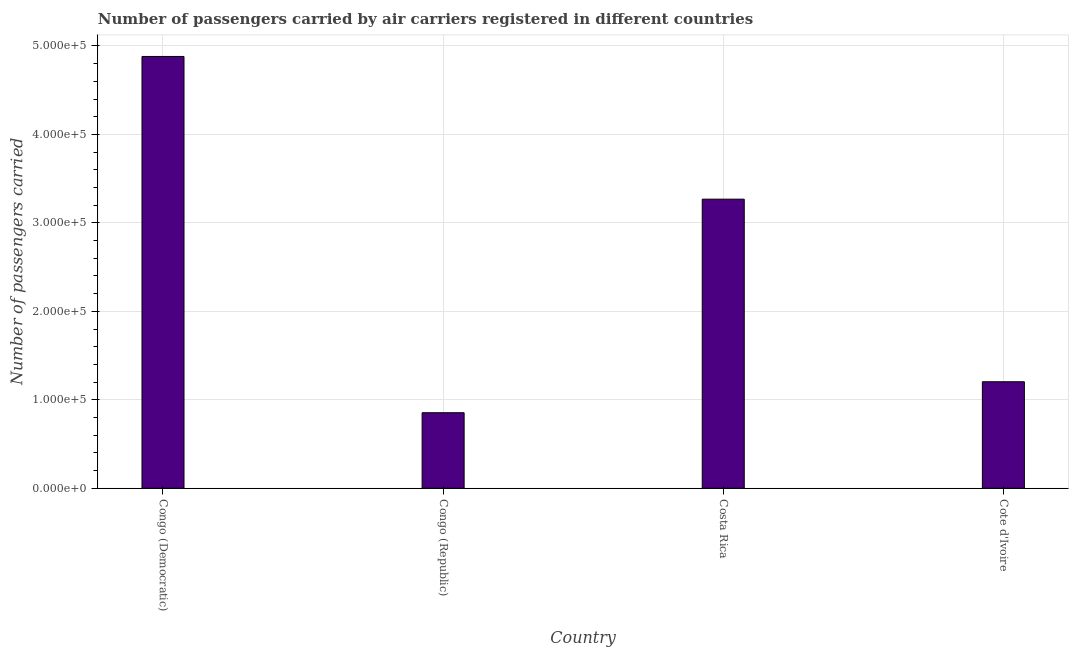Does the graph contain any zero values?
Make the answer very short. No. What is the title of the graph?
Ensure brevity in your answer.  Number of passengers carried by air carriers registered in different countries. What is the label or title of the Y-axis?
Keep it short and to the point. Number of passengers carried. What is the number of passengers carried in Costa Rica?
Offer a very short reply. 3.27e+05. Across all countries, what is the maximum number of passengers carried?
Your response must be concise. 4.88e+05. Across all countries, what is the minimum number of passengers carried?
Provide a succinct answer. 8.54e+04. In which country was the number of passengers carried maximum?
Keep it short and to the point. Congo (Democratic). In which country was the number of passengers carried minimum?
Make the answer very short. Congo (Republic). What is the sum of the number of passengers carried?
Your answer should be very brief. 1.02e+06. What is the difference between the number of passengers carried in Congo (Republic) and Cote d'Ivoire?
Make the answer very short. -3.50e+04. What is the average number of passengers carried per country?
Provide a succinct answer. 2.55e+05. What is the median number of passengers carried?
Ensure brevity in your answer.  2.24e+05. What is the ratio of the number of passengers carried in Congo (Republic) to that in Cote d'Ivoire?
Offer a very short reply. 0.71. Is the number of passengers carried in Congo (Democratic) less than that in Cote d'Ivoire?
Ensure brevity in your answer.  No. What is the difference between the highest and the second highest number of passengers carried?
Provide a succinct answer. 1.61e+05. What is the difference between the highest and the lowest number of passengers carried?
Make the answer very short. 4.03e+05. How many bars are there?
Your response must be concise. 4. What is the difference between two consecutive major ticks on the Y-axis?
Keep it short and to the point. 1.00e+05. What is the Number of passengers carried in Congo (Democratic)?
Make the answer very short. 4.88e+05. What is the Number of passengers carried in Congo (Republic)?
Ensure brevity in your answer.  8.54e+04. What is the Number of passengers carried of Costa Rica?
Keep it short and to the point. 3.27e+05. What is the Number of passengers carried in Cote d'Ivoire?
Your answer should be very brief. 1.20e+05. What is the difference between the Number of passengers carried in Congo (Democratic) and Congo (Republic)?
Keep it short and to the point. 4.03e+05. What is the difference between the Number of passengers carried in Congo (Democratic) and Costa Rica?
Ensure brevity in your answer.  1.61e+05. What is the difference between the Number of passengers carried in Congo (Democratic) and Cote d'Ivoire?
Give a very brief answer. 3.68e+05. What is the difference between the Number of passengers carried in Congo (Republic) and Costa Rica?
Your answer should be very brief. -2.41e+05. What is the difference between the Number of passengers carried in Congo (Republic) and Cote d'Ivoire?
Give a very brief answer. -3.50e+04. What is the difference between the Number of passengers carried in Costa Rica and Cote d'Ivoire?
Your answer should be very brief. 2.06e+05. What is the ratio of the Number of passengers carried in Congo (Democratic) to that in Congo (Republic)?
Provide a short and direct response. 5.71. What is the ratio of the Number of passengers carried in Congo (Democratic) to that in Costa Rica?
Your response must be concise. 1.49. What is the ratio of the Number of passengers carried in Congo (Democratic) to that in Cote d'Ivoire?
Offer a terse response. 4.05. What is the ratio of the Number of passengers carried in Congo (Republic) to that in Costa Rica?
Give a very brief answer. 0.26. What is the ratio of the Number of passengers carried in Congo (Republic) to that in Cote d'Ivoire?
Give a very brief answer. 0.71. What is the ratio of the Number of passengers carried in Costa Rica to that in Cote d'Ivoire?
Keep it short and to the point. 2.71. 